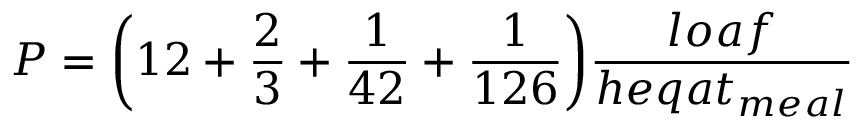Convert formula to latex. <formula><loc_0><loc_0><loc_500><loc_500>P = { \left ( } 1 2 + { \frac { 2 } { 3 } } + { \frac { 1 } { 4 2 } } + { \frac { 1 } { 1 2 6 } } { \right ) } { \frac { l o a f } { h e q a t _ { m e a l } } }</formula> 